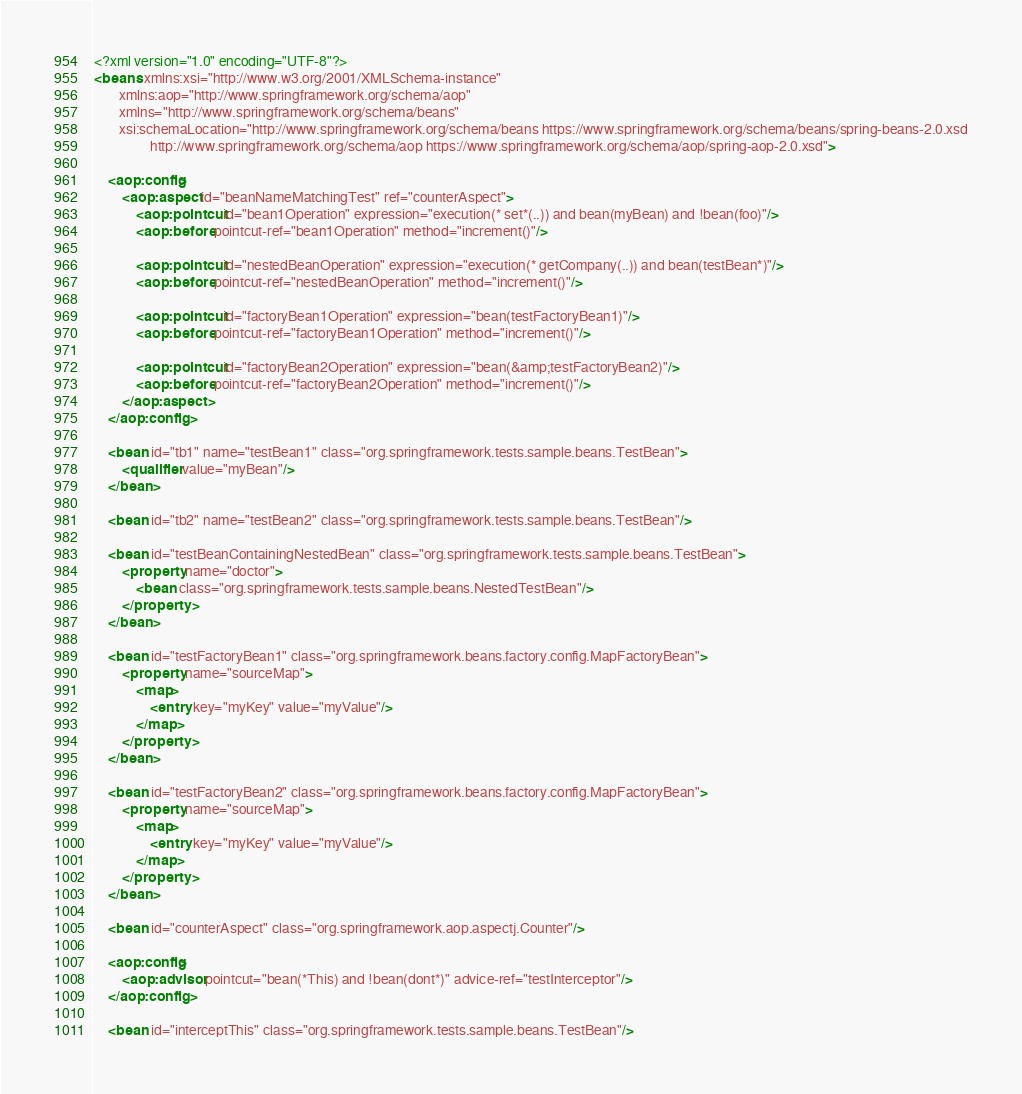<code> <loc_0><loc_0><loc_500><loc_500><_XML_><?xml version="1.0" encoding="UTF-8"?>
<beans xmlns:xsi="http://www.w3.org/2001/XMLSchema-instance"
       xmlns:aop="http://www.springframework.org/schema/aop"
       xmlns="http://www.springframework.org/schema/beans"
       xsi:schemaLocation="http://www.springframework.org/schema/beans https://www.springframework.org/schema/beans/spring-beans-2.0.xsd
				http://www.springframework.org/schema/aop https://www.springframework.org/schema/aop/spring-aop-2.0.xsd">

    <aop:config>
        <aop:aspect id="beanNameMatchingTest" ref="counterAspect">
            <aop:pointcut id="bean1Operation" expression="execution(* set*(..)) and bean(myBean) and !bean(foo)"/>
            <aop:before pointcut-ref="bean1Operation" method="increment()"/>

            <aop:pointcut id="nestedBeanOperation" expression="execution(* getCompany(..)) and bean(testBean*)"/>
            <aop:before pointcut-ref="nestedBeanOperation" method="increment()"/>

            <aop:pointcut id="factoryBean1Operation" expression="bean(testFactoryBean1)"/>
            <aop:before pointcut-ref="factoryBean1Operation" method="increment()"/>

            <aop:pointcut id="factoryBean2Operation" expression="bean(&amp;testFactoryBean2)"/>
            <aop:before pointcut-ref="factoryBean2Operation" method="increment()"/>
        </aop:aspect>
    </aop:config>

    <bean id="tb1" name="testBean1" class="org.springframework.tests.sample.beans.TestBean">
        <qualifier value="myBean"/>
    </bean>

    <bean id="tb2" name="testBean2" class="org.springframework.tests.sample.beans.TestBean"/>

    <bean id="testBeanContainingNestedBean" class="org.springframework.tests.sample.beans.TestBean">
        <property name="doctor">
            <bean class="org.springframework.tests.sample.beans.NestedTestBean"/>
        </property>
    </bean>

    <bean id="testFactoryBean1" class="org.springframework.beans.factory.config.MapFactoryBean">
        <property name="sourceMap">
            <map>
                <entry key="myKey" value="myValue"/>
            </map>
        </property>
    </bean>

    <bean id="testFactoryBean2" class="org.springframework.beans.factory.config.MapFactoryBean">
        <property name="sourceMap">
            <map>
                <entry key="myKey" value="myValue"/>
            </map>
        </property>
    </bean>

    <bean id="counterAspect" class="org.springframework.aop.aspectj.Counter"/>

    <aop:config>
        <aop:advisor pointcut="bean(*This) and !bean(dont*)" advice-ref="testInterceptor"/>
    </aop:config>

    <bean id="interceptThis" class="org.springframework.tests.sample.beans.TestBean"/>
</code> 